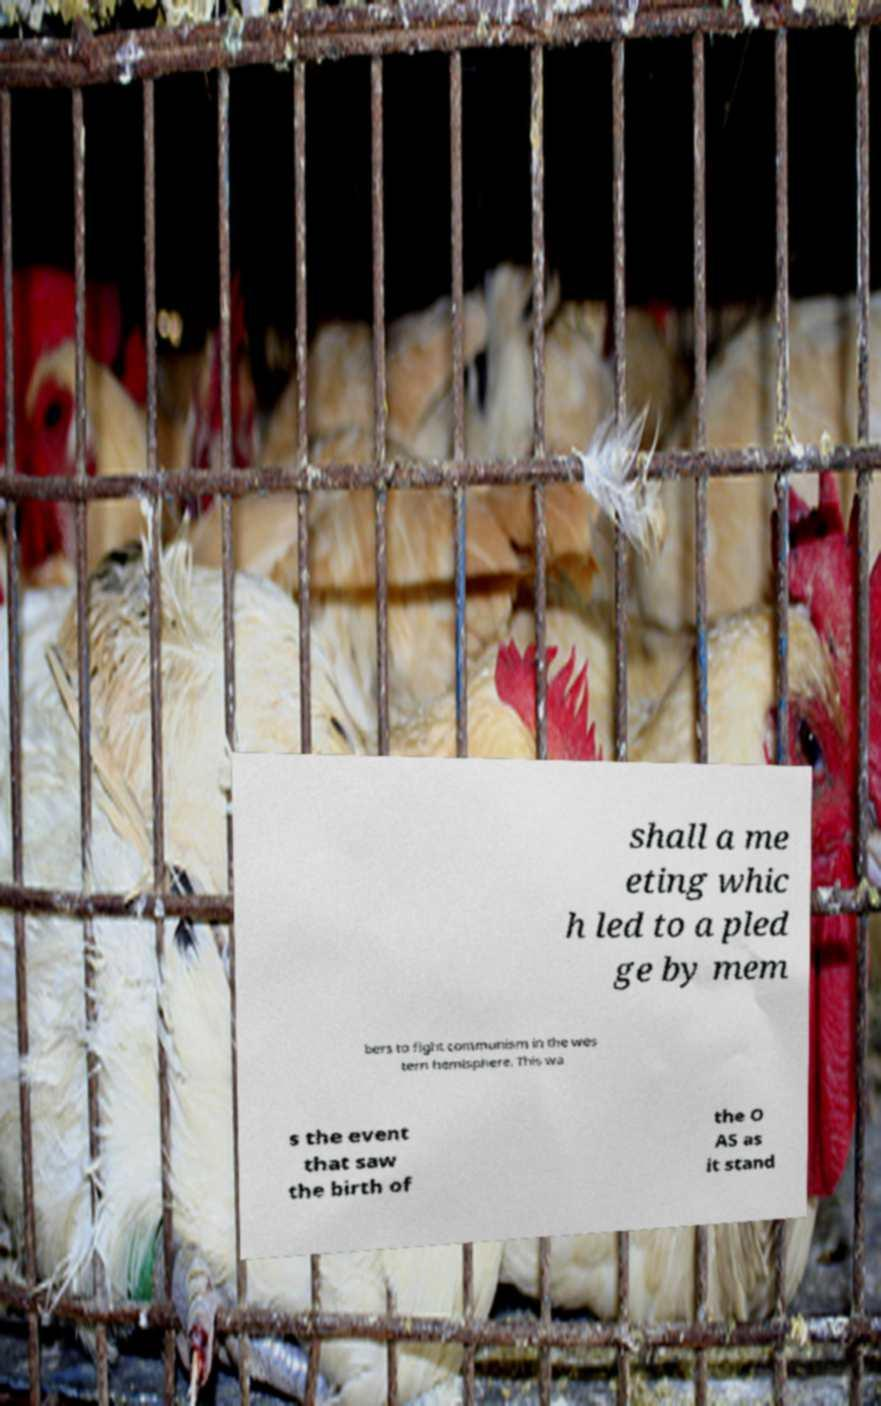Can you accurately transcribe the text from the provided image for me? shall a me eting whic h led to a pled ge by mem bers to fight communism in the wes tern hemisphere. This wa s the event that saw the birth of the O AS as it stand 